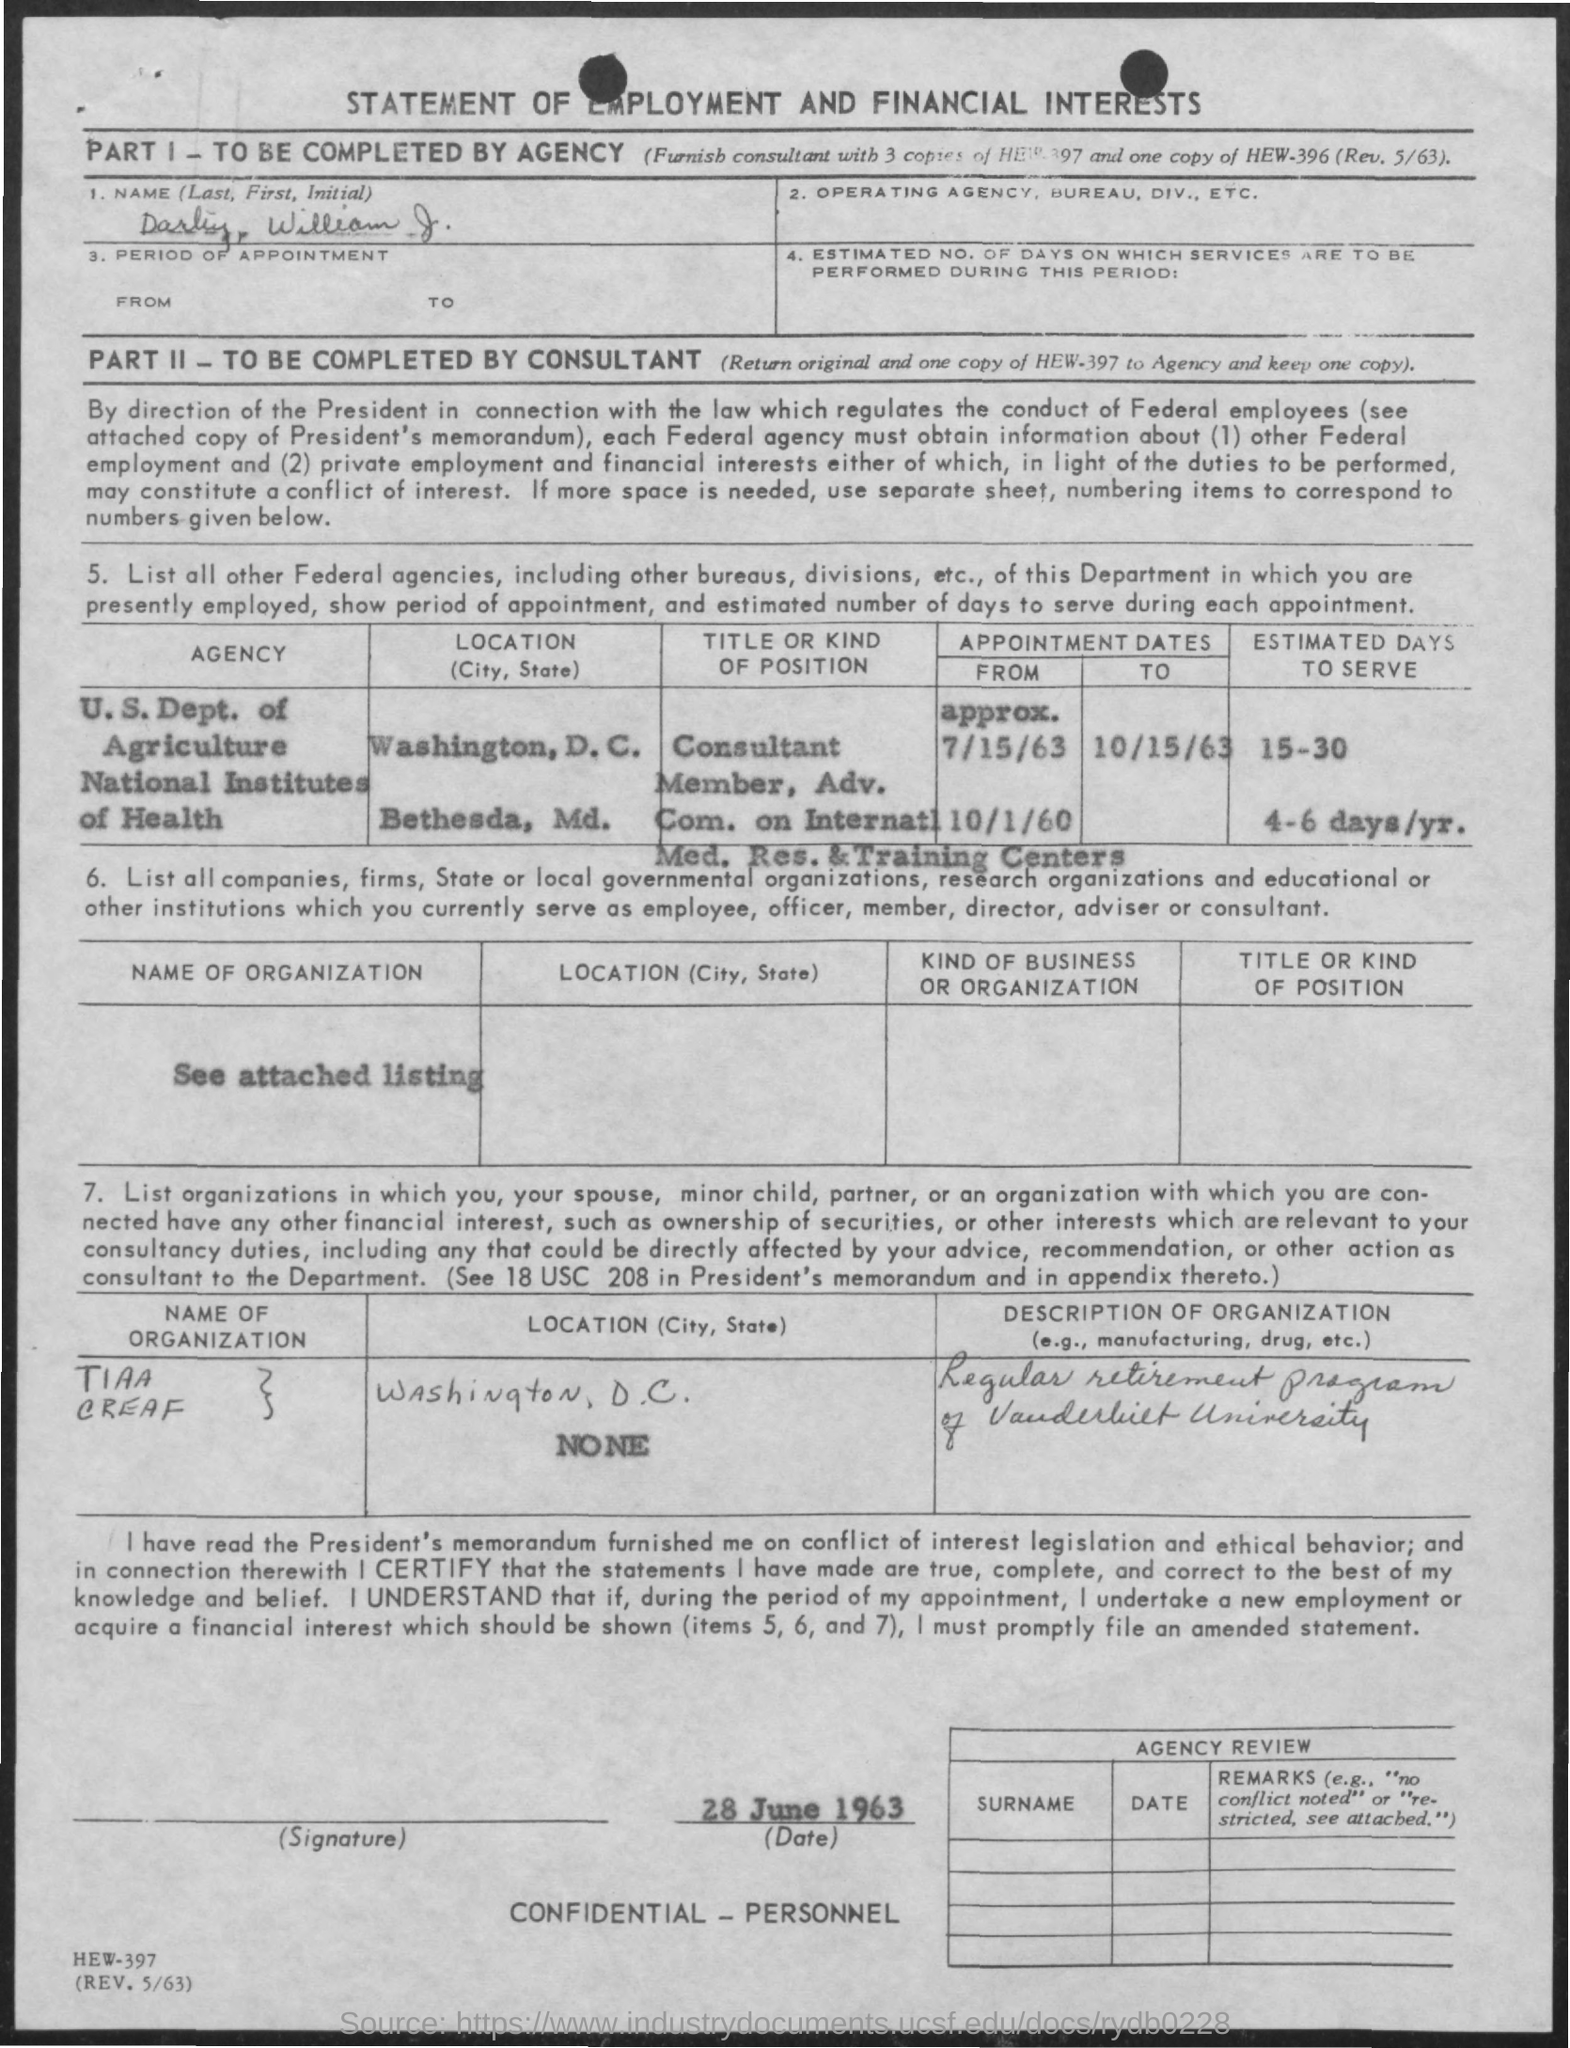Specify some key components in this picture. TIAA CREF is located in Washington, D.C. The National Institutes of Health is located in Bethesda, Maryland. The first name mentioned in the given application is William. The dates for appointments at the National Institutes of Health (NIH) from October 1, 1960, have been provided. The date mentioned in the given page is June 28, 1963. 